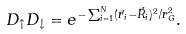<formula> <loc_0><loc_0><loc_500><loc_500>D _ { \uparrow } D _ { \downarrow } = e ^ { - \sum _ { i = 1 } ^ { N } ( \vec { r } _ { i } - \vec { R } _ { i } ) ^ { 2 } / r _ { G } ^ { 2 } } .</formula> 